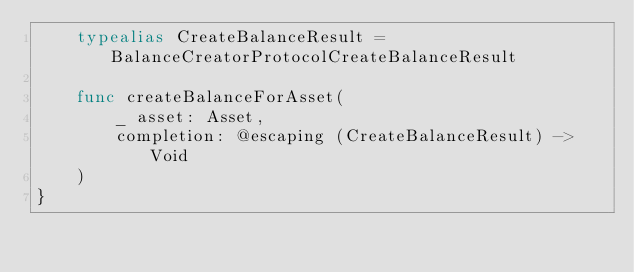<code> <loc_0><loc_0><loc_500><loc_500><_Swift_>    typealias CreateBalanceResult = BalanceCreatorProtocolCreateBalanceResult
    
    func createBalanceForAsset(
        _ asset: Asset,
        completion: @escaping (CreateBalanceResult) -> Void
    )
}
</code> 